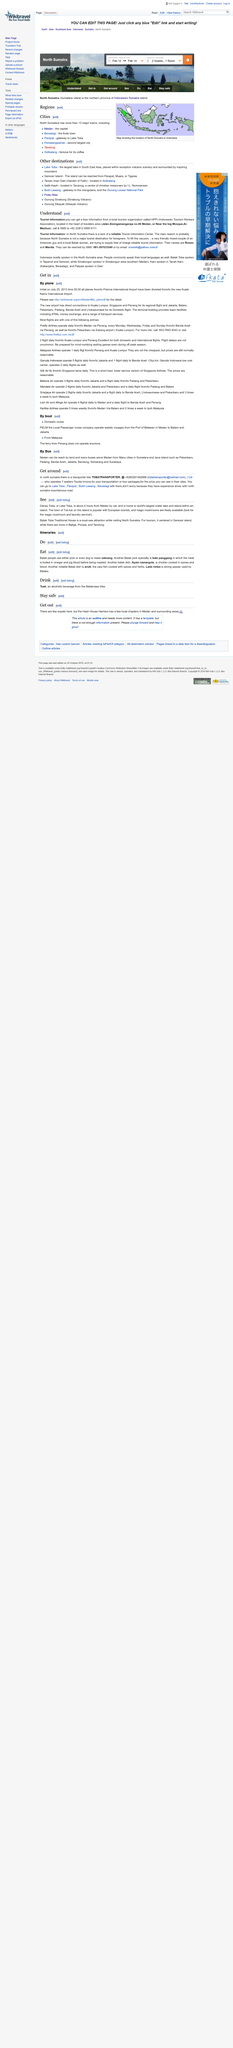Give some essential details in this illustration. The island attractions include crater lakes, magic mushrooms, and Batak Toba Traditional Houses, which provide visitors with a unique and diverse experience. Firefly Airlines operates daily flights from Medan, Indonesia to Penang, Malaysia via Medan, Indonesia, providing convenient connections for passengers traveling between the two cities. Yes, both Garuda Indonesia and Silk Air operate multiple flights daily. The town of Tuk-tuk is popular with European tourists. Malaysia Airlines operates one daily flight from Penang to Kuala Lumpur and vice versa. 